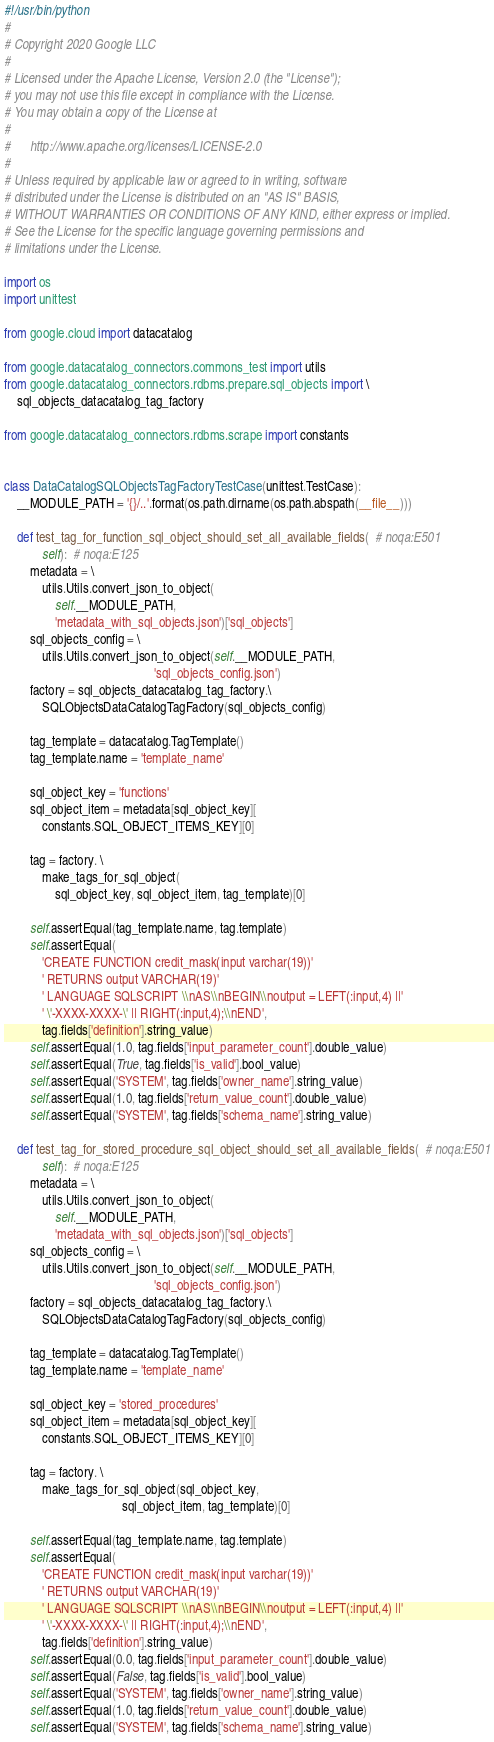Convert code to text. <code><loc_0><loc_0><loc_500><loc_500><_Python_>#!/usr/bin/python
#
# Copyright 2020 Google LLC
#
# Licensed under the Apache License, Version 2.0 (the "License");
# you may not use this file except in compliance with the License.
# You may obtain a copy of the License at
#
#      http://www.apache.org/licenses/LICENSE-2.0
#
# Unless required by applicable law or agreed to in writing, software
# distributed under the License is distributed on an "AS IS" BASIS,
# WITHOUT WARRANTIES OR CONDITIONS OF ANY KIND, either express or implied.
# See the License for the specific language governing permissions and
# limitations under the License.

import os
import unittest

from google.cloud import datacatalog

from google.datacatalog_connectors.commons_test import utils
from google.datacatalog_connectors.rdbms.prepare.sql_objects import \
    sql_objects_datacatalog_tag_factory

from google.datacatalog_connectors.rdbms.scrape import constants


class DataCatalogSQLObjectsTagFactoryTestCase(unittest.TestCase):
    __MODULE_PATH = '{}/..'.format(os.path.dirname(os.path.abspath(__file__)))

    def test_tag_for_function_sql_object_should_set_all_available_fields(  # noqa:E501
            self):  # noqa:E125
        metadata = \
            utils.Utils.convert_json_to_object(
                self.__MODULE_PATH,
                'metadata_with_sql_objects.json')['sql_objects']
        sql_objects_config = \
            utils.Utils.convert_json_to_object(self.__MODULE_PATH,
                                               'sql_objects_config.json')
        factory = sql_objects_datacatalog_tag_factory.\
            SQLObjectsDataCatalogTagFactory(sql_objects_config)

        tag_template = datacatalog.TagTemplate()
        tag_template.name = 'template_name'

        sql_object_key = 'functions'
        sql_object_item = metadata[sql_object_key][
            constants.SQL_OBJECT_ITEMS_KEY][0]

        tag = factory. \
            make_tags_for_sql_object(
                sql_object_key, sql_object_item, tag_template)[0]

        self.assertEqual(tag_template.name, tag.template)
        self.assertEqual(
            'CREATE FUNCTION credit_mask(input varchar(19))'
            ' RETURNS output VARCHAR(19)'
            ' LANGUAGE SQLSCRIPT \\nAS\\nBEGIN\\noutput = LEFT(:input,4) ||'
            ' \'-XXXX-XXXX-\' || RIGHT(:input,4);\\nEND',
            tag.fields['definition'].string_value)
        self.assertEqual(1.0, tag.fields['input_parameter_count'].double_value)
        self.assertEqual(True, tag.fields['is_valid'].bool_value)
        self.assertEqual('SYSTEM', tag.fields['owner_name'].string_value)
        self.assertEqual(1.0, tag.fields['return_value_count'].double_value)
        self.assertEqual('SYSTEM', tag.fields['schema_name'].string_value)

    def test_tag_for_stored_procedure_sql_object_should_set_all_available_fields(  # noqa:E501
            self):  # noqa:E125
        metadata = \
            utils.Utils.convert_json_to_object(
                self.__MODULE_PATH,
                'metadata_with_sql_objects.json')['sql_objects']
        sql_objects_config = \
            utils.Utils.convert_json_to_object(self.__MODULE_PATH,
                                               'sql_objects_config.json')
        factory = sql_objects_datacatalog_tag_factory.\
            SQLObjectsDataCatalogTagFactory(sql_objects_config)

        tag_template = datacatalog.TagTemplate()
        tag_template.name = 'template_name'

        sql_object_key = 'stored_procedures'
        sql_object_item = metadata[sql_object_key][
            constants.SQL_OBJECT_ITEMS_KEY][0]

        tag = factory. \
            make_tags_for_sql_object(sql_object_key,
                                     sql_object_item, tag_template)[0]

        self.assertEqual(tag_template.name, tag.template)
        self.assertEqual(
            'CREATE FUNCTION credit_mask(input varchar(19))'
            ' RETURNS output VARCHAR(19)'
            ' LANGUAGE SQLSCRIPT \\nAS\\nBEGIN\\noutput = LEFT(:input,4) ||'
            ' \'-XXXX-XXXX-\' || RIGHT(:input,4);\\nEND',
            tag.fields['definition'].string_value)
        self.assertEqual(0.0, tag.fields['input_parameter_count'].double_value)
        self.assertEqual(False, tag.fields['is_valid'].bool_value)
        self.assertEqual('SYSTEM', tag.fields['owner_name'].string_value)
        self.assertEqual(1.0, tag.fields['return_value_count'].double_value)
        self.assertEqual('SYSTEM', tag.fields['schema_name'].string_value)
</code> 